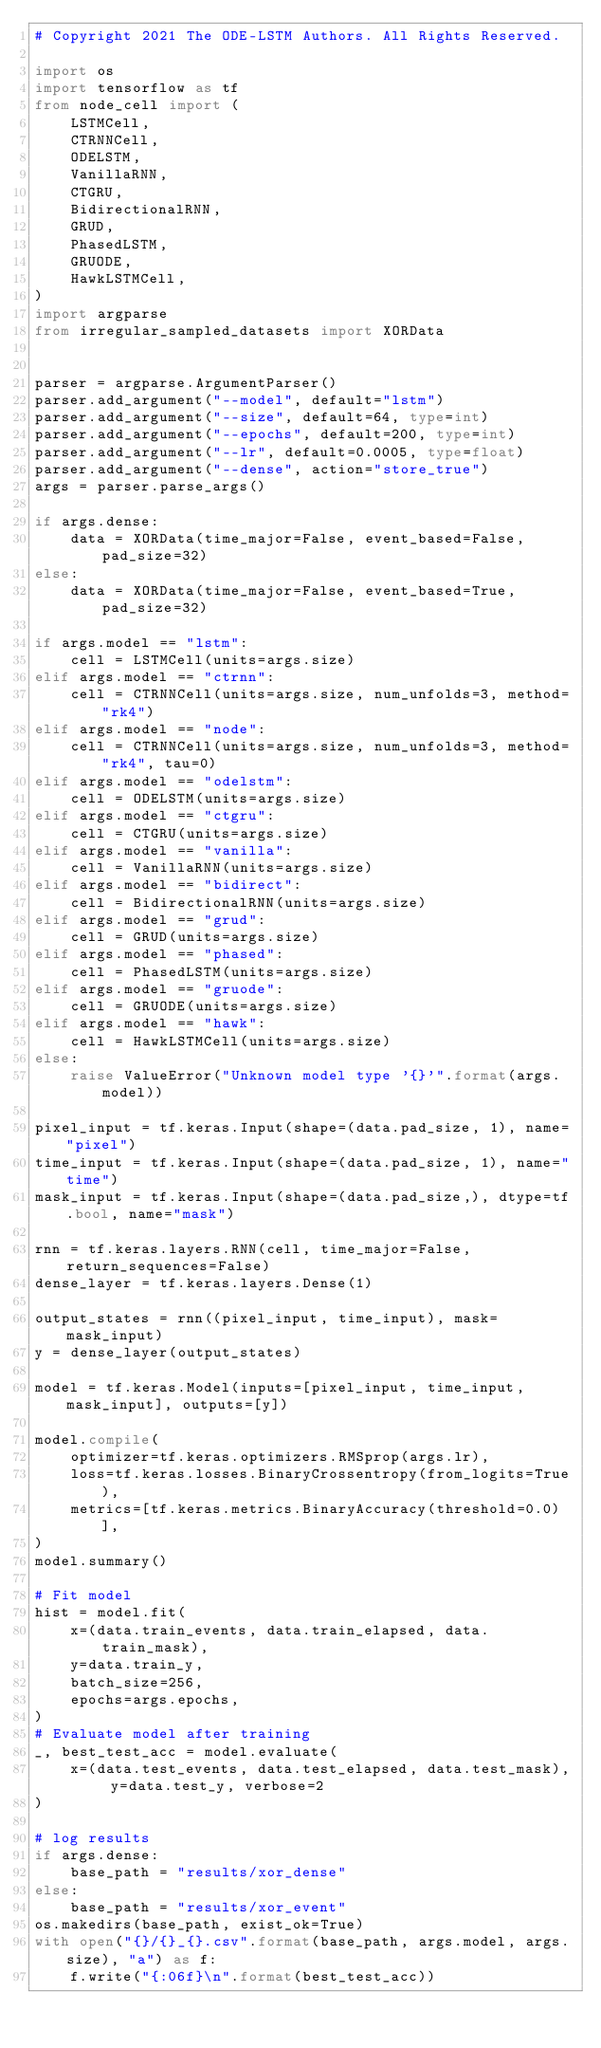Convert code to text. <code><loc_0><loc_0><loc_500><loc_500><_Python_># Copyright 2021 The ODE-LSTM Authors. All Rights Reserved.

import os
import tensorflow as tf
from node_cell import (
    LSTMCell,
    CTRNNCell,
    ODELSTM,
    VanillaRNN,
    CTGRU,
    BidirectionalRNN,
    GRUD,
    PhasedLSTM,
    GRUODE,
    HawkLSTMCell,
)
import argparse
from irregular_sampled_datasets import XORData


parser = argparse.ArgumentParser()
parser.add_argument("--model", default="lstm")
parser.add_argument("--size", default=64, type=int)
parser.add_argument("--epochs", default=200, type=int)
parser.add_argument("--lr", default=0.0005, type=float)
parser.add_argument("--dense", action="store_true")
args = parser.parse_args()

if args.dense:
    data = XORData(time_major=False, event_based=False, pad_size=32)
else:
    data = XORData(time_major=False, event_based=True, pad_size=32)

if args.model == "lstm":
    cell = LSTMCell(units=args.size)
elif args.model == "ctrnn":
    cell = CTRNNCell(units=args.size, num_unfolds=3, method="rk4")
elif args.model == "node":
    cell = CTRNNCell(units=args.size, num_unfolds=3, method="rk4", tau=0)
elif args.model == "odelstm":
    cell = ODELSTM(units=args.size)
elif args.model == "ctgru":
    cell = CTGRU(units=args.size)
elif args.model == "vanilla":
    cell = VanillaRNN(units=args.size)
elif args.model == "bidirect":
    cell = BidirectionalRNN(units=args.size)
elif args.model == "grud":
    cell = GRUD(units=args.size)
elif args.model == "phased":
    cell = PhasedLSTM(units=args.size)
elif args.model == "gruode":
    cell = GRUODE(units=args.size)
elif args.model == "hawk":
    cell = HawkLSTMCell(units=args.size)
else:
    raise ValueError("Unknown model type '{}'".format(args.model))

pixel_input = tf.keras.Input(shape=(data.pad_size, 1), name="pixel")
time_input = tf.keras.Input(shape=(data.pad_size, 1), name="time")
mask_input = tf.keras.Input(shape=(data.pad_size,), dtype=tf.bool, name="mask")

rnn = tf.keras.layers.RNN(cell, time_major=False, return_sequences=False)
dense_layer = tf.keras.layers.Dense(1)

output_states = rnn((pixel_input, time_input), mask=mask_input)
y = dense_layer(output_states)

model = tf.keras.Model(inputs=[pixel_input, time_input, mask_input], outputs=[y])

model.compile(
    optimizer=tf.keras.optimizers.RMSprop(args.lr),
    loss=tf.keras.losses.BinaryCrossentropy(from_logits=True),
    metrics=[tf.keras.metrics.BinaryAccuracy(threshold=0.0)],
)
model.summary()

# Fit model
hist = model.fit(
    x=(data.train_events, data.train_elapsed, data.train_mask),
    y=data.train_y,
    batch_size=256,
    epochs=args.epochs,
)
# Evaluate model after training
_, best_test_acc = model.evaluate(
    x=(data.test_events, data.test_elapsed, data.test_mask), y=data.test_y, verbose=2
)

# log results
if args.dense:
    base_path = "results/xor_dense"
else:
    base_path = "results/xor_event"
os.makedirs(base_path, exist_ok=True)
with open("{}/{}_{}.csv".format(base_path, args.model, args.size), "a") as f:
    f.write("{:06f}\n".format(best_test_acc))</code> 